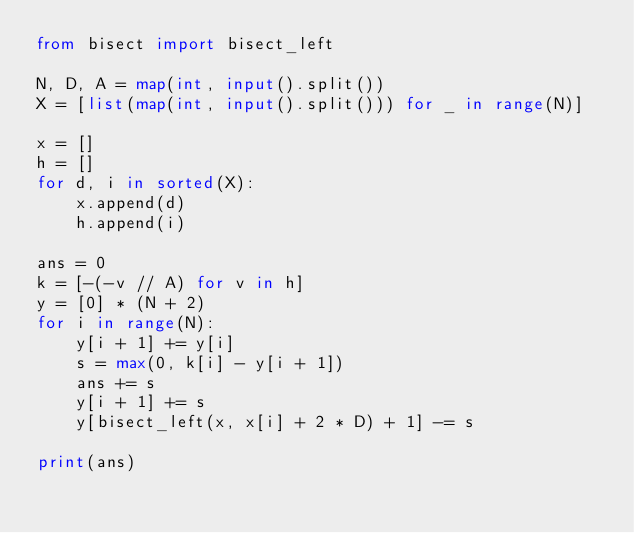<code> <loc_0><loc_0><loc_500><loc_500><_Python_>from bisect import bisect_left

N, D, A = map(int, input().split())
X = [list(map(int, input().split())) for _ in range(N)]

x = []
h = []
for d, i in sorted(X):
    x.append(d)
    h.append(i)

ans = 0
k = [-(-v // A) for v in h]
y = [0] * (N + 2)
for i in range(N):
    y[i + 1] += y[i]
    s = max(0, k[i] - y[i + 1])
    ans += s
    y[i + 1] += s
    y[bisect_left(x, x[i] + 2 * D) + 1] -= s
    
print(ans)
</code> 